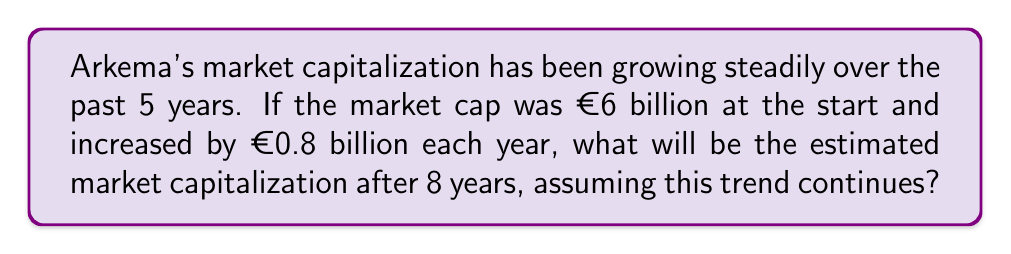Give your solution to this math problem. Let's approach this step-by-step using an arithmetic progression:

1) Initial value (a₁): €6 billion
2) Common difference (d): €0.8 billion per year
3) Number of terms (n): 8 years

We can use the arithmetic sequence formula:
$$ a_n = a_1 + (n-1)d $$

Where:
$a_n$ is the nth term (market cap after 8 years)
$a_1$ is the first term (initial market cap)
$n$ is the number of terms (years)
$d$ is the common difference (yearly increase)

Substituting our values:
$$ a_8 = 6 + (8-1)(0.8) $$

$$ a_8 = 6 + 7(0.8) $$

$$ a_8 = 6 + 5.6 $$

$$ a_8 = 11.6 $$

Therefore, the estimated market capitalization after 8 years would be €11.6 billion.
Answer: €11.6 billion 